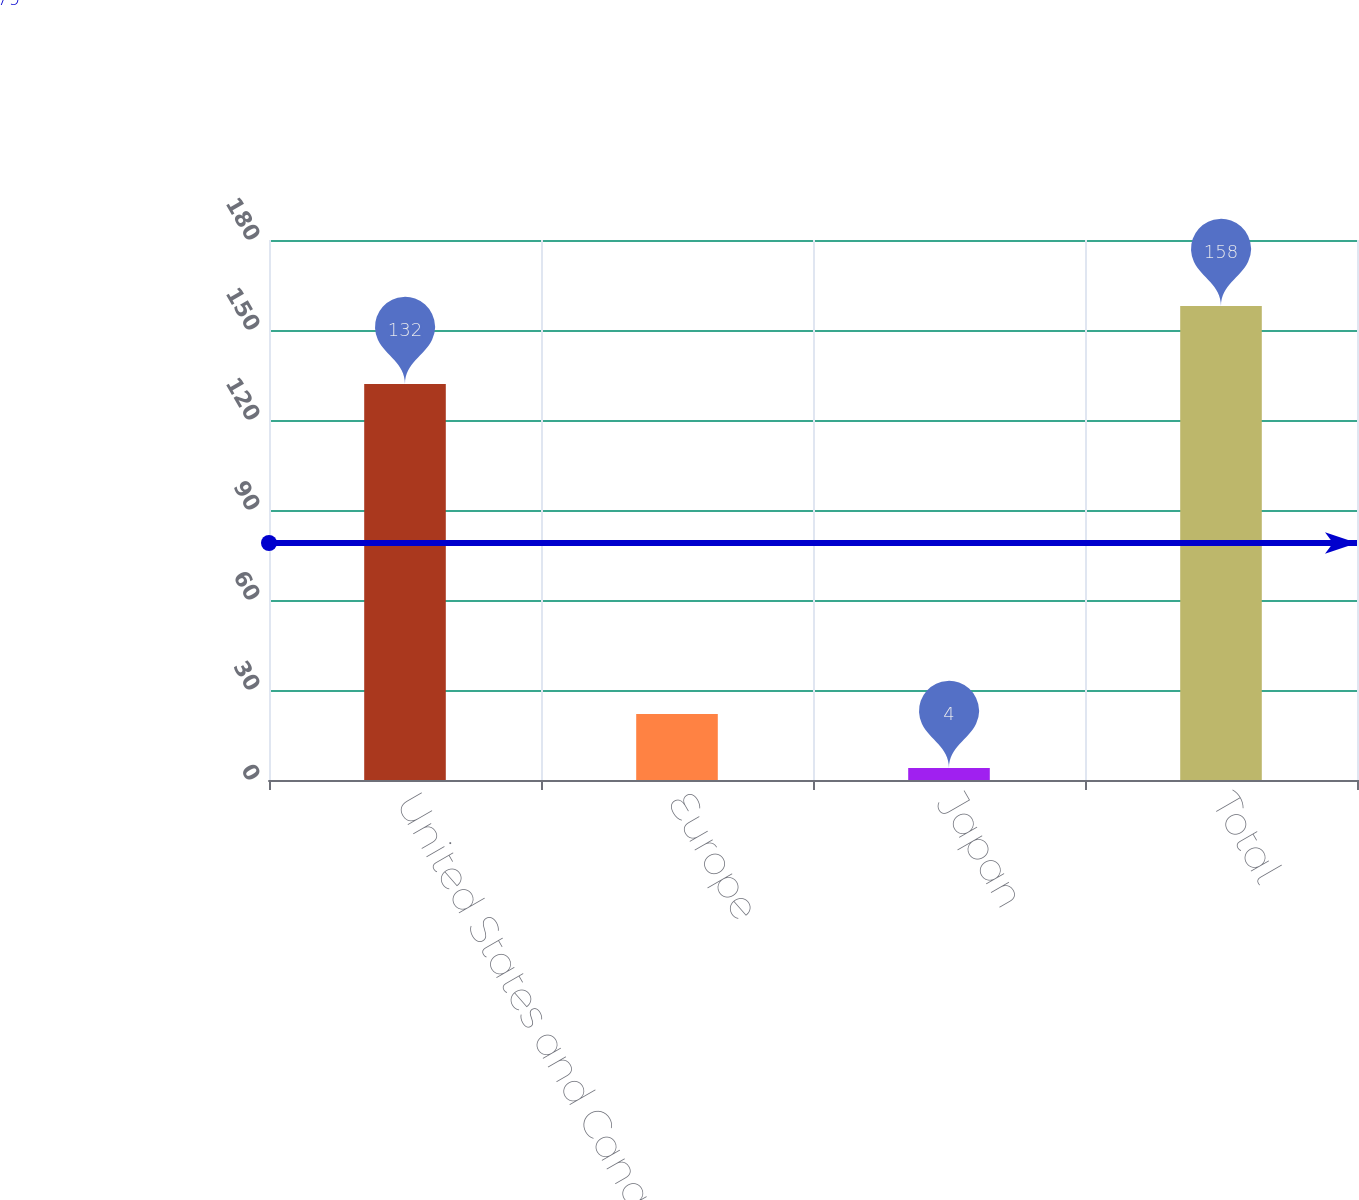<chart> <loc_0><loc_0><loc_500><loc_500><bar_chart><fcel>United States and Canada<fcel>Europe<fcel>Japan<fcel>Total<nl><fcel>132<fcel>22<fcel>4<fcel>158<nl></chart> 